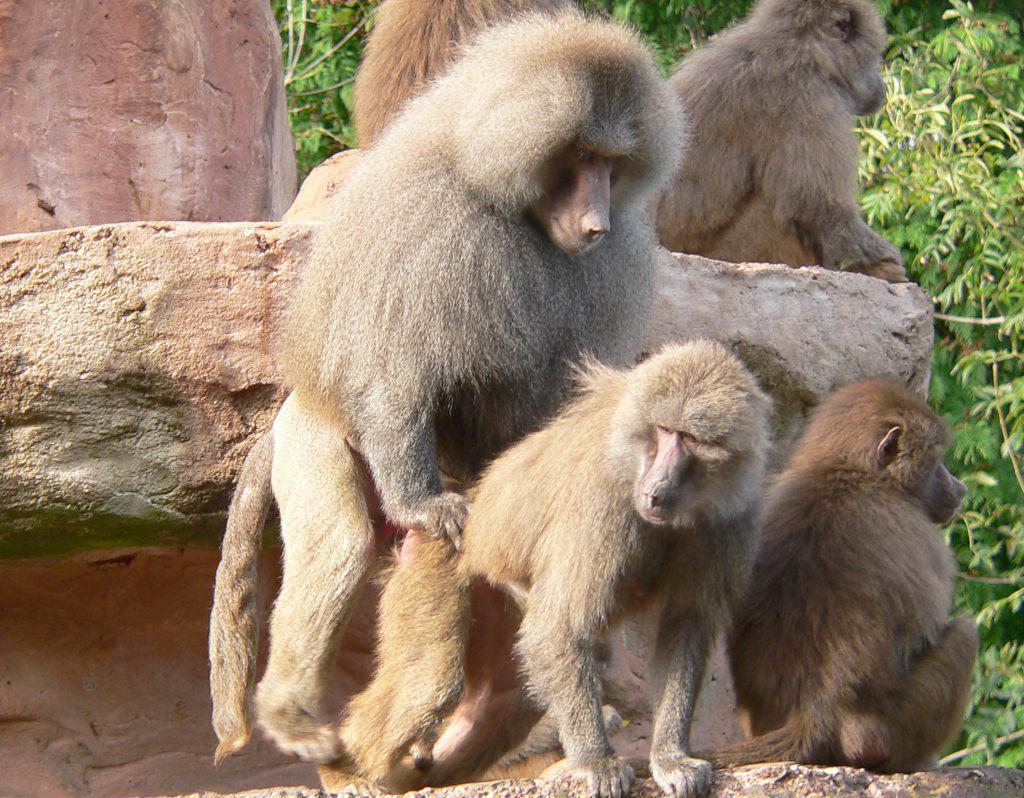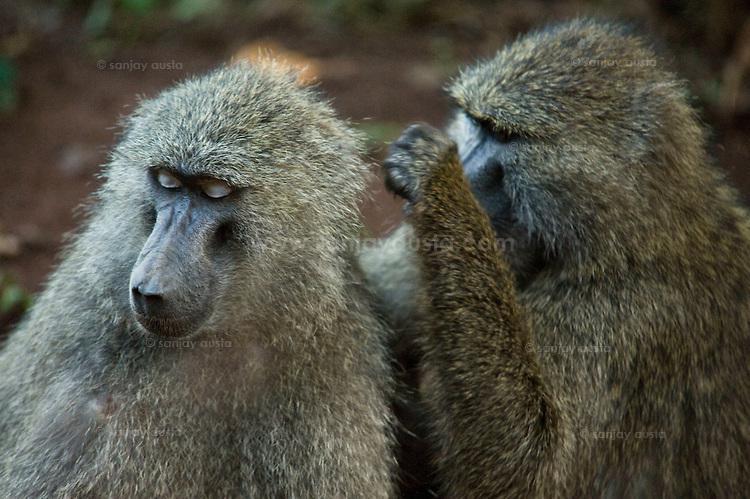The first image is the image on the left, the second image is the image on the right. Given the left and right images, does the statement "There is no more than two baboons in the left image." hold true? Answer yes or no. No. The first image is the image on the left, the second image is the image on the right. Assess this claim about the two images: "There are at least three animals in the image on the left.". Correct or not? Answer yes or no. Yes. 